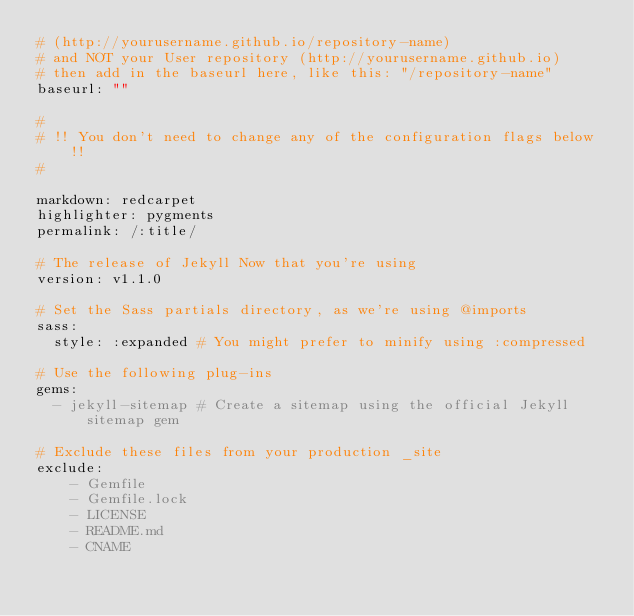Convert code to text. <code><loc_0><loc_0><loc_500><loc_500><_YAML_># (http://yourusername.github.io/repository-name)
# and NOT your User repository (http://yourusername.github.io)
# then add in the baseurl here, like this: "/repository-name"
baseurl: ""

#
# !! You don't need to change any of the configuration flags below !!
#

markdown: redcarpet
highlighter: pygments
permalink: /:title/

# The release of Jekyll Now that you're using
version: v1.1.0

# Set the Sass partials directory, as we're using @imports
sass:
  style: :expanded # You might prefer to minify using :compressed

# Use the following plug-ins
gems:
  - jekyll-sitemap # Create a sitemap using the official Jekyll sitemap gem

# Exclude these files from your production _site
exclude:
    - Gemfile
    - Gemfile.lock
    - LICENSE
    - README.md
    - CNAME
</code> 